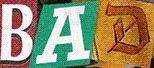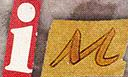Transcribe the words shown in these images in order, separated by a semicolon. BAD; iM 